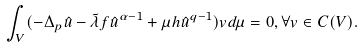Convert formula to latex. <formula><loc_0><loc_0><loc_500><loc_500>\int _ { V } ( - \Delta _ { p } \hat { u } - \tilde { \lambda } f \hat { u } ^ { \alpha - 1 } + \mu h \hat { u } ^ { q - 1 } ) v d \mu = 0 , \forall v \in C ( V ) .</formula> 